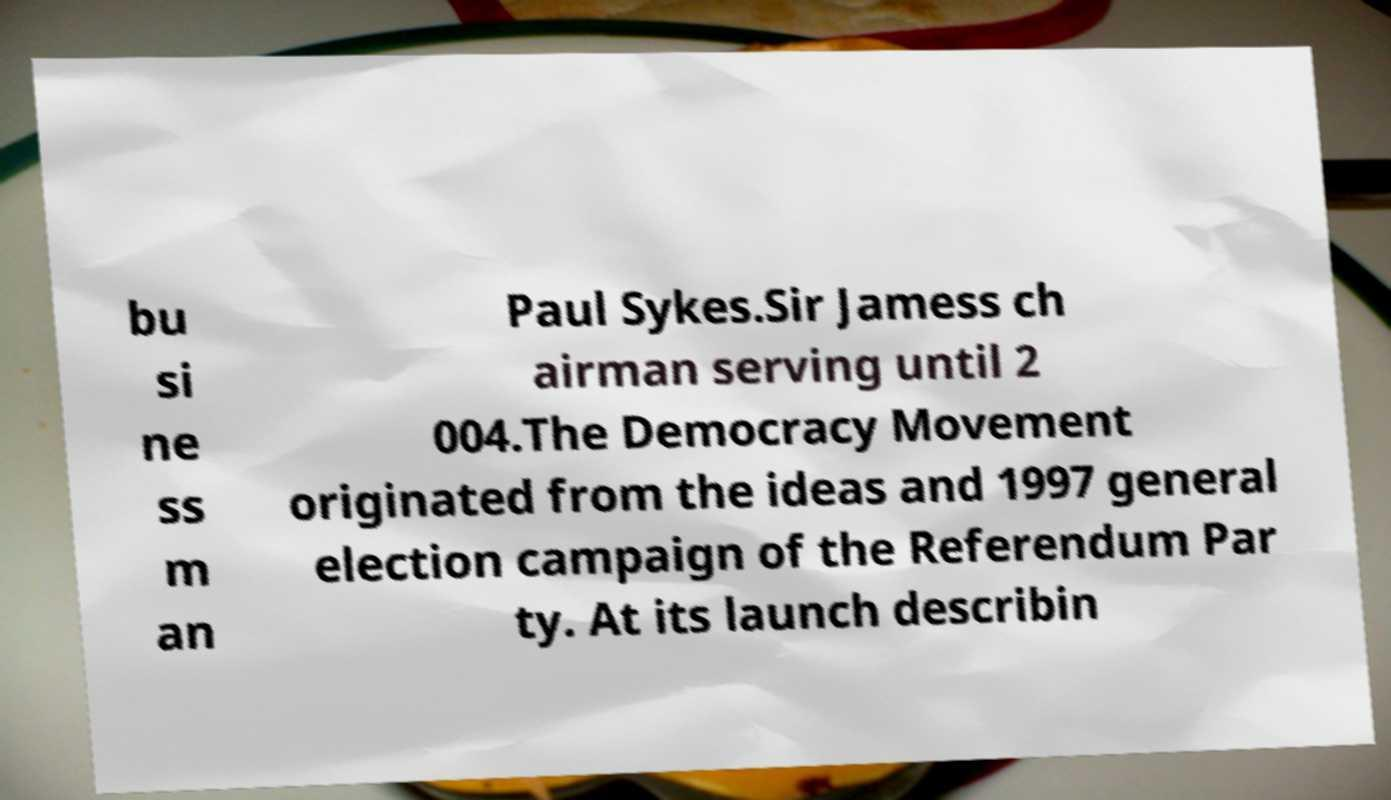Please read and relay the text visible in this image. What does it say? bu si ne ss m an Paul Sykes.Sir Jamess ch airman serving until 2 004.The Democracy Movement originated from the ideas and 1997 general election campaign of the Referendum Par ty. At its launch describin 